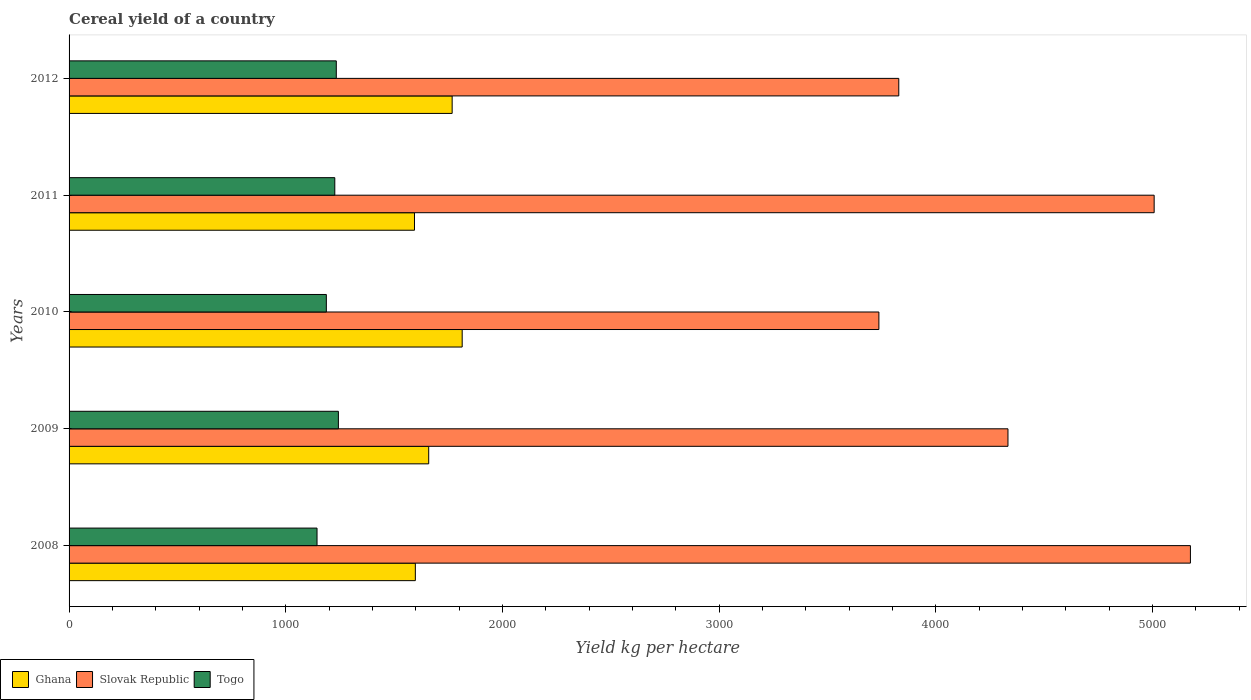How many different coloured bars are there?
Your answer should be compact. 3. Are the number of bars on each tick of the Y-axis equal?
Provide a short and direct response. Yes. How many bars are there on the 4th tick from the top?
Offer a very short reply. 3. What is the label of the 1st group of bars from the top?
Your answer should be very brief. 2012. What is the total cereal yield in Ghana in 2010?
Keep it short and to the point. 1814.31. Across all years, what is the maximum total cereal yield in Ghana?
Keep it short and to the point. 1814.31. Across all years, what is the minimum total cereal yield in Slovak Republic?
Offer a very short reply. 3737.52. In which year was the total cereal yield in Slovak Republic maximum?
Make the answer very short. 2008. In which year was the total cereal yield in Togo minimum?
Keep it short and to the point. 2008. What is the total total cereal yield in Togo in the graph?
Ensure brevity in your answer.  6034.41. What is the difference between the total cereal yield in Togo in 2011 and that in 2012?
Offer a very short reply. -6.92. What is the difference between the total cereal yield in Togo in 2010 and the total cereal yield in Ghana in 2008?
Make the answer very short. -410.76. What is the average total cereal yield in Ghana per year?
Give a very brief answer. 1686.9. In the year 2010, what is the difference between the total cereal yield in Slovak Republic and total cereal yield in Togo?
Offer a terse response. 2550.15. In how many years, is the total cereal yield in Togo greater than 2400 kg per hectare?
Keep it short and to the point. 0. What is the ratio of the total cereal yield in Slovak Republic in 2008 to that in 2011?
Keep it short and to the point. 1.03. What is the difference between the highest and the second highest total cereal yield in Slovak Republic?
Ensure brevity in your answer.  167.38. What is the difference between the highest and the lowest total cereal yield in Ghana?
Keep it short and to the point. 220.15. Is the sum of the total cereal yield in Slovak Republic in 2008 and 2012 greater than the maximum total cereal yield in Ghana across all years?
Ensure brevity in your answer.  Yes. What does the 2nd bar from the top in 2012 represents?
Keep it short and to the point. Slovak Republic. Is it the case that in every year, the sum of the total cereal yield in Ghana and total cereal yield in Togo is greater than the total cereal yield in Slovak Republic?
Ensure brevity in your answer.  No. How many bars are there?
Ensure brevity in your answer.  15. Are all the bars in the graph horizontal?
Your answer should be compact. Yes. How many years are there in the graph?
Provide a succinct answer. 5. What is the difference between two consecutive major ticks on the X-axis?
Your answer should be very brief. 1000. Are the values on the major ticks of X-axis written in scientific E-notation?
Provide a succinct answer. No. Does the graph contain any zero values?
Keep it short and to the point. No. Where does the legend appear in the graph?
Provide a succinct answer. Bottom left. How many legend labels are there?
Your response must be concise. 3. How are the legend labels stacked?
Ensure brevity in your answer.  Horizontal. What is the title of the graph?
Give a very brief answer. Cereal yield of a country. What is the label or title of the X-axis?
Offer a terse response. Yield kg per hectare. What is the label or title of the Y-axis?
Provide a short and direct response. Years. What is the Yield kg per hectare in Ghana in 2008?
Offer a terse response. 1598.13. What is the Yield kg per hectare in Slovak Republic in 2008?
Provide a short and direct response. 5175.32. What is the Yield kg per hectare in Togo in 2008?
Your response must be concise. 1144.42. What is the Yield kg per hectare in Ghana in 2009?
Make the answer very short. 1659.83. What is the Yield kg per hectare in Slovak Republic in 2009?
Your answer should be very brief. 4333.23. What is the Yield kg per hectare of Togo in 2009?
Provide a succinct answer. 1242.94. What is the Yield kg per hectare in Ghana in 2010?
Provide a succinct answer. 1814.31. What is the Yield kg per hectare in Slovak Republic in 2010?
Ensure brevity in your answer.  3737.52. What is the Yield kg per hectare of Togo in 2010?
Give a very brief answer. 1187.37. What is the Yield kg per hectare in Ghana in 2011?
Make the answer very short. 1594.16. What is the Yield kg per hectare of Slovak Republic in 2011?
Give a very brief answer. 5007.94. What is the Yield kg per hectare in Togo in 2011?
Offer a very short reply. 1226.38. What is the Yield kg per hectare in Ghana in 2012?
Your answer should be compact. 1768.07. What is the Yield kg per hectare in Slovak Republic in 2012?
Your response must be concise. 3829.34. What is the Yield kg per hectare in Togo in 2012?
Your response must be concise. 1233.3. Across all years, what is the maximum Yield kg per hectare in Ghana?
Your answer should be very brief. 1814.31. Across all years, what is the maximum Yield kg per hectare of Slovak Republic?
Keep it short and to the point. 5175.32. Across all years, what is the maximum Yield kg per hectare of Togo?
Your response must be concise. 1242.94. Across all years, what is the minimum Yield kg per hectare in Ghana?
Give a very brief answer. 1594.16. Across all years, what is the minimum Yield kg per hectare of Slovak Republic?
Provide a succinct answer. 3737.52. Across all years, what is the minimum Yield kg per hectare in Togo?
Give a very brief answer. 1144.42. What is the total Yield kg per hectare in Ghana in the graph?
Ensure brevity in your answer.  8434.5. What is the total Yield kg per hectare in Slovak Republic in the graph?
Offer a terse response. 2.21e+04. What is the total Yield kg per hectare of Togo in the graph?
Offer a very short reply. 6034.41. What is the difference between the Yield kg per hectare in Ghana in 2008 and that in 2009?
Keep it short and to the point. -61.7. What is the difference between the Yield kg per hectare of Slovak Republic in 2008 and that in 2009?
Your answer should be compact. 842.09. What is the difference between the Yield kg per hectare of Togo in 2008 and that in 2009?
Keep it short and to the point. -98.53. What is the difference between the Yield kg per hectare in Ghana in 2008 and that in 2010?
Your answer should be very brief. -216.18. What is the difference between the Yield kg per hectare of Slovak Republic in 2008 and that in 2010?
Offer a terse response. 1437.8. What is the difference between the Yield kg per hectare in Togo in 2008 and that in 2010?
Ensure brevity in your answer.  -42.95. What is the difference between the Yield kg per hectare in Ghana in 2008 and that in 2011?
Provide a short and direct response. 3.97. What is the difference between the Yield kg per hectare in Slovak Republic in 2008 and that in 2011?
Provide a short and direct response. 167.38. What is the difference between the Yield kg per hectare of Togo in 2008 and that in 2011?
Give a very brief answer. -81.96. What is the difference between the Yield kg per hectare in Ghana in 2008 and that in 2012?
Ensure brevity in your answer.  -169.94. What is the difference between the Yield kg per hectare in Slovak Republic in 2008 and that in 2012?
Make the answer very short. 1345.98. What is the difference between the Yield kg per hectare in Togo in 2008 and that in 2012?
Offer a very short reply. -88.88. What is the difference between the Yield kg per hectare in Ghana in 2009 and that in 2010?
Your response must be concise. -154.49. What is the difference between the Yield kg per hectare of Slovak Republic in 2009 and that in 2010?
Keep it short and to the point. 595.71. What is the difference between the Yield kg per hectare in Togo in 2009 and that in 2010?
Ensure brevity in your answer.  55.58. What is the difference between the Yield kg per hectare of Ghana in 2009 and that in 2011?
Provide a short and direct response. 65.67. What is the difference between the Yield kg per hectare of Slovak Republic in 2009 and that in 2011?
Your response must be concise. -674.71. What is the difference between the Yield kg per hectare of Togo in 2009 and that in 2011?
Your response must be concise. 16.57. What is the difference between the Yield kg per hectare in Ghana in 2009 and that in 2012?
Your answer should be very brief. -108.24. What is the difference between the Yield kg per hectare in Slovak Republic in 2009 and that in 2012?
Provide a succinct answer. 503.89. What is the difference between the Yield kg per hectare of Togo in 2009 and that in 2012?
Your answer should be compact. 9.65. What is the difference between the Yield kg per hectare of Ghana in 2010 and that in 2011?
Your response must be concise. 220.15. What is the difference between the Yield kg per hectare in Slovak Republic in 2010 and that in 2011?
Provide a short and direct response. -1270.42. What is the difference between the Yield kg per hectare in Togo in 2010 and that in 2011?
Provide a short and direct response. -39.01. What is the difference between the Yield kg per hectare of Ghana in 2010 and that in 2012?
Make the answer very short. 46.25. What is the difference between the Yield kg per hectare of Slovak Republic in 2010 and that in 2012?
Keep it short and to the point. -91.82. What is the difference between the Yield kg per hectare of Togo in 2010 and that in 2012?
Ensure brevity in your answer.  -45.93. What is the difference between the Yield kg per hectare of Ghana in 2011 and that in 2012?
Ensure brevity in your answer.  -173.91. What is the difference between the Yield kg per hectare in Slovak Republic in 2011 and that in 2012?
Your response must be concise. 1178.6. What is the difference between the Yield kg per hectare of Togo in 2011 and that in 2012?
Provide a short and direct response. -6.92. What is the difference between the Yield kg per hectare of Ghana in 2008 and the Yield kg per hectare of Slovak Republic in 2009?
Offer a very short reply. -2735.1. What is the difference between the Yield kg per hectare in Ghana in 2008 and the Yield kg per hectare in Togo in 2009?
Offer a very short reply. 355.19. What is the difference between the Yield kg per hectare of Slovak Republic in 2008 and the Yield kg per hectare of Togo in 2009?
Ensure brevity in your answer.  3932.38. What is the difference between the Yield kg per hectare of Ghana in 2008 and the Yield kg per hectare of Slovak Republic in 2010?
Provide a short and direct response. -2139.39. What is the difference between the Yield kg per hectare in Ghana in 2008 and the Yield kg per hectare in Togo in 2010?
Make the answer very short. 410.76. What is the difference between the Yield kg per hectare in Slovak Republic in 2008 and the Yield kg per hectare in Togo in 2010?
Your answer should be compact. 3987.95. What is the difference between the Yield kg per hectare in Ghana in 2008 and the Yield kg per hectare in Slovak Republic in 2011?
Offer a very short reply. -3409.81. What is the difference between the Yield kg per hectare in Ghana in 2008 and the Yield kg per hectare in Togo in 2011?
Your answer should be compact. 371.75. What is the difference between the Yield kg per hectare in Slovak Republic in 2008 and the Yield kg per hectare in Togo in 2011?
Your answer should be very brief. 3948.95. What is the difference between the Yield kg per hectare in Ghana in 2008 and the Yield kg per hectare in Slovak Republic in 2012?
Your response must be concise. -2231.21. What is the difference between the Yield kg per hectare of Ghana in 2008 and the Yield kg per hectare of Togo in 2012?
Provide a short and direct response. 364.83. What is the difference between the Yield kg per hectare in Slovak Republic in 2008 and the Yield kg per hectare in Togo in 2012?
Give a very brief answer. 3942.03. What is the difference between the Yield kg per hectare in Ghana in 2009 and the Yield kg per hectare in Slovak Republic in 2010?
Keep it short and to the point. -2077.69. What is the difference between the Yield kg per hectare in Ghana in 2009 and the Yield kg per hectare in Togo in 2010?
Ensure brevity in your answer.  472.46. What is the difference between the Yield kg per hectare of Slovak Republic in 2009 and the Yield kg per hectare of Togo in 2010?
Provide a short and direct response. 3145.86. What is the difference between the Yield kg per hectare in Ghana in 2009 and the Yield kg per hectare in Slovak Republic in 2011?
Offer a very short reply. -3348.12. What is the difference between the Yield kg per hectare in Ghana in 2009 and the Yield kg per hectare in Togo in 2011?
Keep it short and to the point. 433.45. What is the difference between the Yield kg per hectare of Slovak Republic in 2009 and the Yield kg per hectare of Togo in 2011?
Give a very brief answer. 3106.85. What is the difference between the Yield kg per hectare of Ghana in 2009 and the Yield kg per hectare of Slovak Republic in 2012?
Give a very brief answer. -2169.51. What is the difference between the Yield kg per hectare of Ghana in 2009 and the Yield kg per hectare of Togo in 2012?
Provide a short and direct response. 426.53. What is the difference between the Yield kg per hectare of Slovak Republic in 2009 and the Yield kg per hectare of Togo in 2012?
Make the answer very short. 3099.93. What is the difference between the Yield kg per hectare of Ghana in 2010 and the Yield kg per hectare of Slovak Republic in 2011?
Give a very brief answer. -3193.63. What is the difference between the Yield kg per hectare of Ghana in 2010 and the Yield kg per hectare of Togo in 2011?
Offer a very short reply. 587.94. What is the difference between the Yield kg per hectare in Slovak Republic in 2010 and the Yield kg per hectare in Togo in 2011?
Give a very brief answer. 2511.14. What is the difference between the Yield kg per hectare of Ghana in 2010 and the Yield kg per hectare of Slovak Republic in 2012?
Offer a terse response. -2015.03. What is the difference between the Yield kg per hectare in Ghana in 2010 and the Yield kg per hectare in Togo in 2012?
Offer a terse response. 581.02. What is the difference between the Yield kg per hectare of Slovak Republic in 2010 and the Yield kg per hectare of Togo in 2012?
Offer a very short reply. 2504.22. What is the difference between the Yield kg per hectare in Ghana in 2011 and the Yield kg per hectare in Slovak Republic in 2012?
Make the answer very short. -2235.18. What is the difference between the Yield kg per hectare of Ghana in 2011 and the Yield kg per hectare of Togo in 2012?
Make the answer very short. 360.86. What is the difference between the Yield kg per hectare in Slovak Republic in 2011 and the Yield kg per hectare in Togo in 2012?
Provide a succinct answer. 3774.64. What is the average Yield kg per hectare of Ghana per year?
Ensure brevity in your answer.  1686.9. What is the average Yield kg per hectare of Slovak Republic per year?
Make the answer very short. 4416.67. What is the average Yield kg per hectare in Togo per year?
Ensure brevity in your answer.  1206.88. In the year 2008, what is the difference between the Yield kg per hectare in Ghana and Yield kg per hectare in Slovak Republic?
Provide a succinct answer. -3577.19. In the year 2008, what is the difference between the Yield kg per hectare of Ghana and Yield kg per hectare of Togo?
Your response must be concise. 453.71. In the year 2008, what is the difference between the Yield kg per hectare of Slovak Republic and Yield kg per hectare of Togo?
Make the answer very short. 4030.91. In the year 2009, what is the difference between the Yield kg per hectare in Ghana and Yield kg per hectare in Slovak Republic?
Your answer should be compact. -2673.41. In the year 2009, what is the difference between the Yield kg per hectare in Ghana and Yield kg per hectare in Togo?
Your answer should be very brief. 416.88. In the year 2009, what is the difference between the Yield kg per hectare of Slovak Republic and Yield kg per hectare of Togo?
Keep it short and to the point. 3090.29. In the year 2010, what is the difference between the Yield kg per hectare in Ghana and Yield kg per hectare in Slovak Republic?
Provide a succinct answer. -1923.2. In the year 2010, what is the difference between the Yield kg per hectare of Ghana and Yield kg per hectare of Togo?
Your answer should be very brief. 626.95. In the year 2010, what is the difference between the Yield kg per hectare of Slovak Republic and Yield kg per hectare of Togo?
Give a very brief answer. 2550.15. In the year 2011, what is the difference between the Yield kg per hectare in Ghana and Yield kg per hectare in Slovak Republic?
Provide a short and direct response. -3413.78. In the year 2011, what is the difference between the Yield kg per hectare of Ghana and Yield kg per hectare of Togo?
Ensure brevity in your answer.  367.78. In the year 2011, what is the difference between the Yield kg per hectare in Slovak Republic and Yield kg per hectare in Togo?
Your answer should be compact. 3781.57. In the year 2012, what is the difference between the Yield kg per hectare in Ghana and Yield kg per hectare in Slovak Republic?
Ensure brevity in your answer.  -2061.27. In the year 2012, what is the difference between the Yield kg per hectare of Ghana and Yield kg per hectare of Togo?
Your answer should be very brief. 534.77. In the year 2012, what is the difference between the Yield kg per hectare of Slovak Republic and Yield kg per hectare of Togo?
Offer a terse response. 2596.04. What is the ratio of the Yield kg per hectare in Ghana in 2008 to that in 2009?
Give a very brief answer. 0.96. What is the ratio of the Yield kg per hectare in Slovak Republic in 2008 to that in 2009?
Make the answer very short. 1.19. What is the ratio of the Yield kg per hectare in Togo in 2008 to that in 2009?
Your response must be concise. 0.92. What is the ratio of the Yield kg per hectare in Ghana in 2008 to that in 2010?
Keep it short and to the point. 0.88. What is the ratio of the Yield kg per hectare of Slovak Republic in 2008 to that in 2010?
Your answer should be very brief. 1.38. What is the ratio of the Yield kg per hectare in Togo in 2008 to that in 2010?
Keep it short and to the point. 0.96. What is the ratio of the Yield kg per hectare in Slovak Republic in 2008 to that in 2011?
Make the answer very short. 1.03. What is the ratio of the Yield kg per hectare in Togo in 2008 to that in 2011?
Make the answer very short. 0.93. What is the ratio of the Yield kg per hectare in Ghana in 2008 to that in 2012?
Offer a very short reply. 0.9. What is the ratio of the Yield kg per hectare of Slovak Republic in 2008 to that in 2012?
Provide a short and direct response. 1.35. What is the ratio of the Yield kg per hectare of Togo in 2008 to that in 2012?
Your answer should be compact. 0.93. What is the ratio of the Yield kg per hectare in Ghana in 2009 to that in 2010?
Your answer should be very brief. 0.91. What is the ratio of the Yield kg per hectare of Slovak Republic in 2009 to that in 2010?
Your response must be concise. 1.16. What is the ratio of the Yield kg per hectare in Togo in 2009 to that in 2010?
Make the answer very short. 1.05. What is the ratio of the Yield kg per hectare in Ghana in 2009 to that in 2011?
Give a very brief answer. 1.04. What is the ratio of the Yield kg per hectare of Slovak Republic in 2009 to that in 2011?
Ensure brevity in your answer.  0.87. What is the ratio of the Yield kg per hectare in Togo in 2009 to that in 2011?
Provide a succinct answer. 1.01. What is the ratio of the Yield kg per hectare in Ghana in 2009 to that in 2012?
Your answer should be compact. 0.94. What is the ratio of the Yield kg per hectare in Slovak Republic in 2009 to that in 2012?
Offer a very short reply. 1.13. What is the ratio of the Yield kg per hectare of Togo in 2009 to that in 2012?
Keep it short and to the point. 1.01. What is the ratio of the Yield kg per hectare in Ghana in 2010 to that in 2011?
Keep it short and to the point. 1.14. What is the ratio of the Yield kg per hectare in Slovak Republic in 2010 to that in 2011?
Your response must be concise. 0.75. What is the ratio of the Yield kg per hectare of Togo in 2010 to that in 2011?
Your response must be concise. 0.97. What is the ratio of the Yield kg per hectare of Ghana in 2010 to that in 2012?
Provide a short and direct response. 1.03. What is the ratio of the Yield kg per hectare of Togo in 2010 to that in 2012?
Keep it short and to the point. 0.96. What is the ratio of the Yield kg per hectare in Ghana in 2011 to that in 2012?
Your response must be concise. 0.9. What is the ratio of the Yield kg per hectare in Slovak Republic in 2011 to that in 2012?
Offer a terse response. 1.31. What is the difference between the highest and the second highest Yield kg per hectare in Ghana?
Your response must be concise. 46.25. What is the difference between the highest and the second highest Yield kg per hectare in Slovak Republic?
Keep it short and to the point. 167.38. What is the difference between the highest and the second highest Yield kg per hectare in Togo?
Make the answer very short. 9.65. What is the difference between the highest and the lowest Yield kg per hectare of Ghana?
Give a very brief answer. 220.15. What is the difference between the highest and the lowest Yield kg per hectare in Slovak Republic?
Give a very brief answer. 1437.8. What is the difference between the highest and the lowest Yield kg per hectare in Togo?
Your answer should be compact. 98.53. 